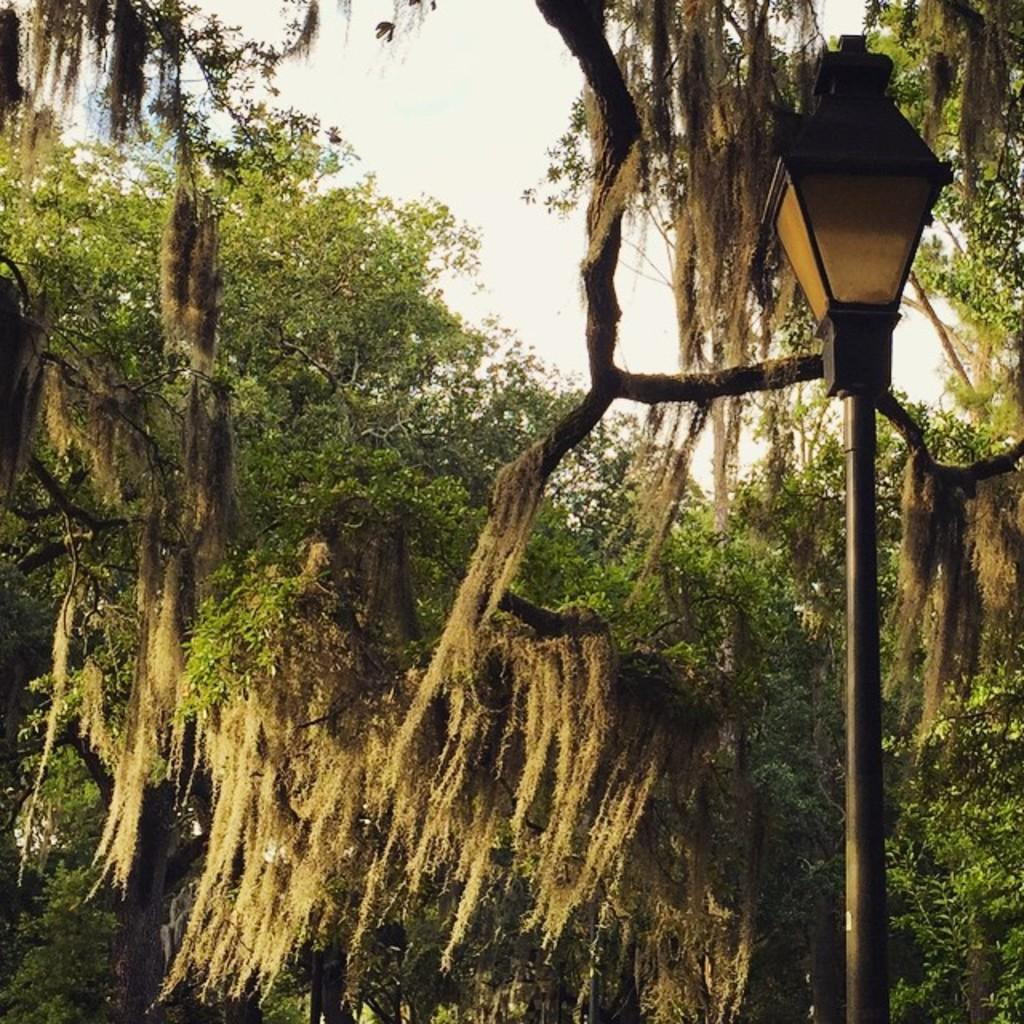What structure can be seen in the image? There is a light pole in the image. What type of vegetation is present in the image? There are trees in the image. What is visible in the background of the image? The sky is visible in the image. How many eggs can be seen in the image? There are no eggs present in the image. Is there an owl perched on the light pole in the image? There is no owl present in the image. 